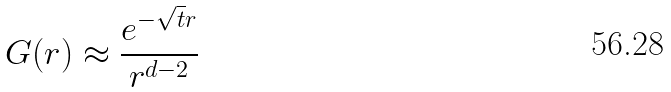Convert formula to latex. <formula><loc_0><loc_0><loc_500><loc_500>G ( r ) \approx \frac { e ^ { - \sqrt { t } r } } { r ^ { d - 2 } }</formula> 